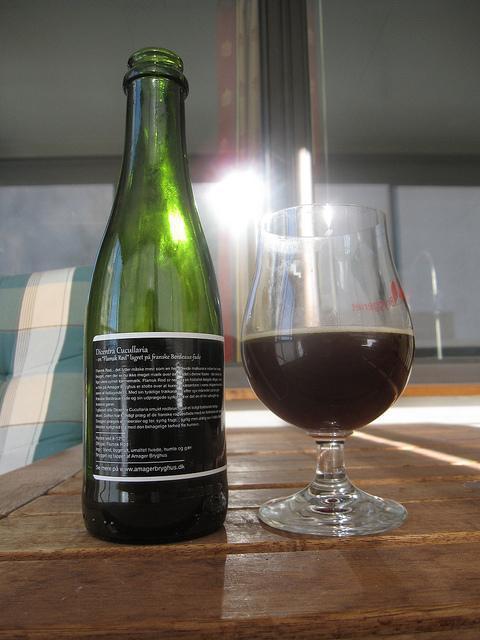Is "The dining table is touching the bottle." an appropriate description for the image?
Answer yes or no. Yes. 